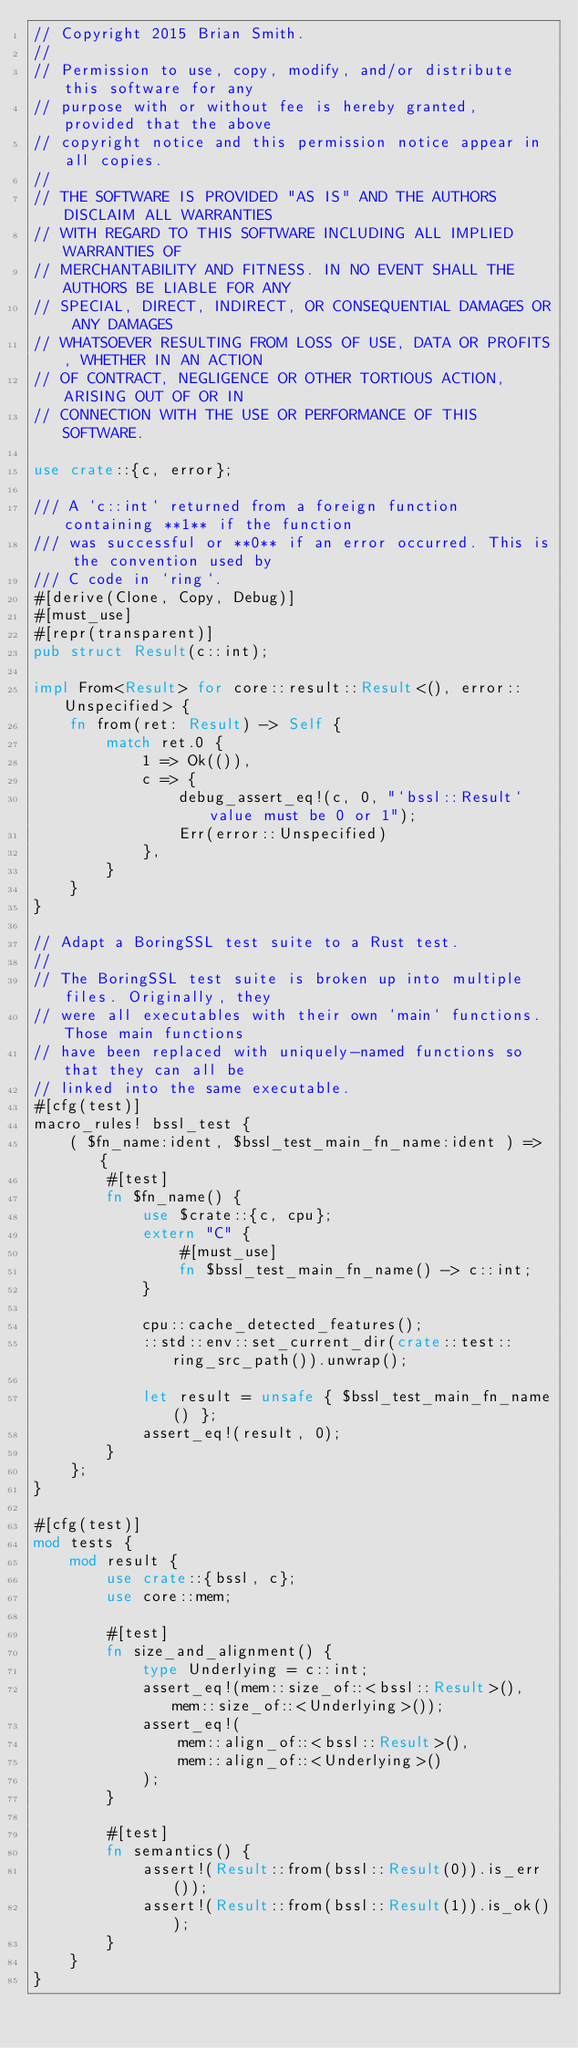<code> <loc_0><loc_0><loc_500><loc_500><_Rust_>// Copyright 2015 Brian Smith.
//
// Permission to use, copy, modify, and/or distribute this software for any
// purpose with or without fee is hereby granted, provided that the above
// copyright notice and this permission notice appear in all copies.
//
// THE SOFTWARE IS PROVIDED "AS IS" AND THE AUTHORS DISCLAIM ALL WARRANTIES
// WITH REGARD TO THIS SOFTWARE INCLUDING ALL IMPLIED WARRANTIES OF
// MERCHANTABILITY AND FITNESS. IN NO EVENT SHALL THE AUTHORS BE LIABLE FOR ANY
// SPECIAL, DIRECT, INDIRECT, OR CONSEQUENTIAL DAMAGES OR ANY DAMAGES
// WHATSOEVER RESULTING FROM LOSS OF USE, DATA OR PROFITS, WHETHER IN AN ACTION
// OF CONTRACT, NEGLIGENCE OR OTHER TORTIOUS ACTION, ARISING OUT OF OR IN
// CONNECTION WITH THE USE OR PERFORMANCE OF THIS SOFTWARE.

use crate::{c, error};

/// A `c::int` returned from a foreign function containing **1** if the function
/// was successful or **0** if an error occurred. This is the convention used by
/// C code in `ring`.
#[derive(Clone, Copy, Debug)]
#[must_use]
#[repr(transparent)]
pub struct Result(c::int);

impl From<Result> for core::result::Result<(), error::Unspecified> {
    fn from(ret: Result) -> Self {
        match ret.0 {
            1 => Ok(()),
            c => {
                debug_assert_eq!(c, 0, "`bssl::Result` value must be 0 or 1");
                Err(error::Unspecified)
            },
        }
    }
}

// Adapt a BoringSSL test suite to a Rust test.
//
// The BoringSSL test suite is broken up into multiple files. Originally, they
// were all executables with their own `main` functions. Those main functions
// have been replaced with uniquely-named functions so that they can all be
// linked into the same executable.
#[cfg(test)]
macro_rules! bssl_test {
    ( $fn_name:ident, $bssl_test_main_fn_name:ident ) => {
        #[test]
        fn $fn_name() {
            use $crate::{c, cpu};
            extern "C" {
                #[must_use]
                fn $bssl_test_main_fn_name() -> c::int;
            }

            cpu::cache_detected_features();
            ::std::env::set_current_dir(crate::test::ring_src_path()).unwrap();

            let result = unsafe { $bssl_test_main_fn_name() };
            assert_eq!(result, 0);
        }
    };
}

#[cfg(test)]
mod tests {
    mod result {
        use crate::{bssl, c};
        use core::mem;

        #[test]
        fn size_and_alignment() {
            type Underlying = c::int;
            assert_eq!(mem::size_of::<bssl::Result>(), mem::size_of::<Underlying>());
            assert_eq!(
                mem::align_of::<bssl::Result>(),
                mem::align_of::<Underlying>()
            );
        }

        #[test]
        fn semantics() {
            assert!(Result::from(bssl::Result(0)).is_err());
            assert!(Result::from(bssl::Result(1)).is_ok());
        }
    }
}
</code> 